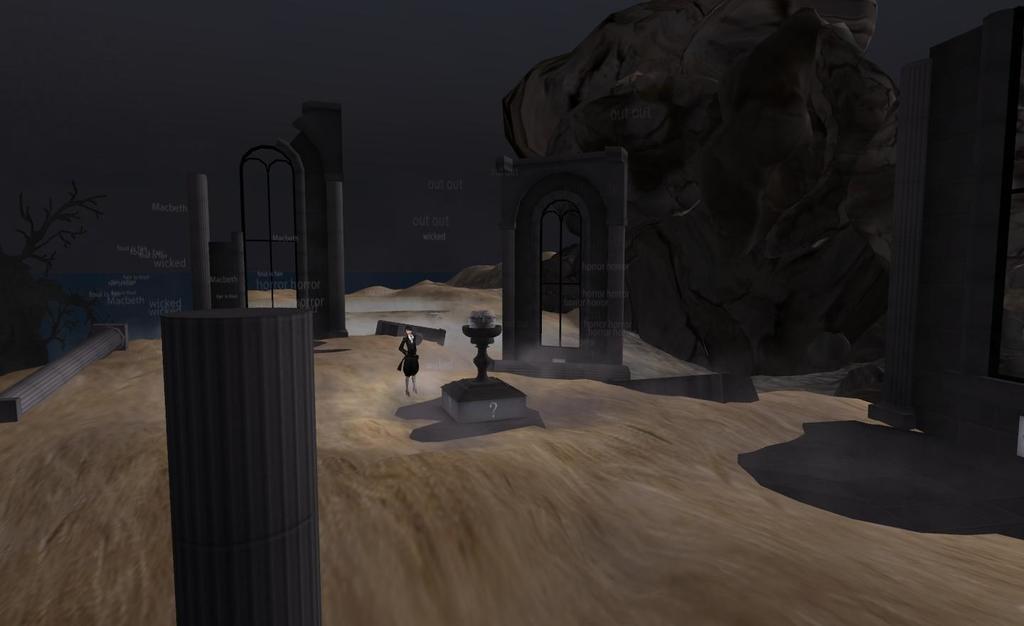Please provide a concise description of this image. This is an animated image. In the middle of the image there is a person standing. Around there pillars. On the right side there is an object which seems to be a rock. On the left side there is a tree. The background is blurred. 